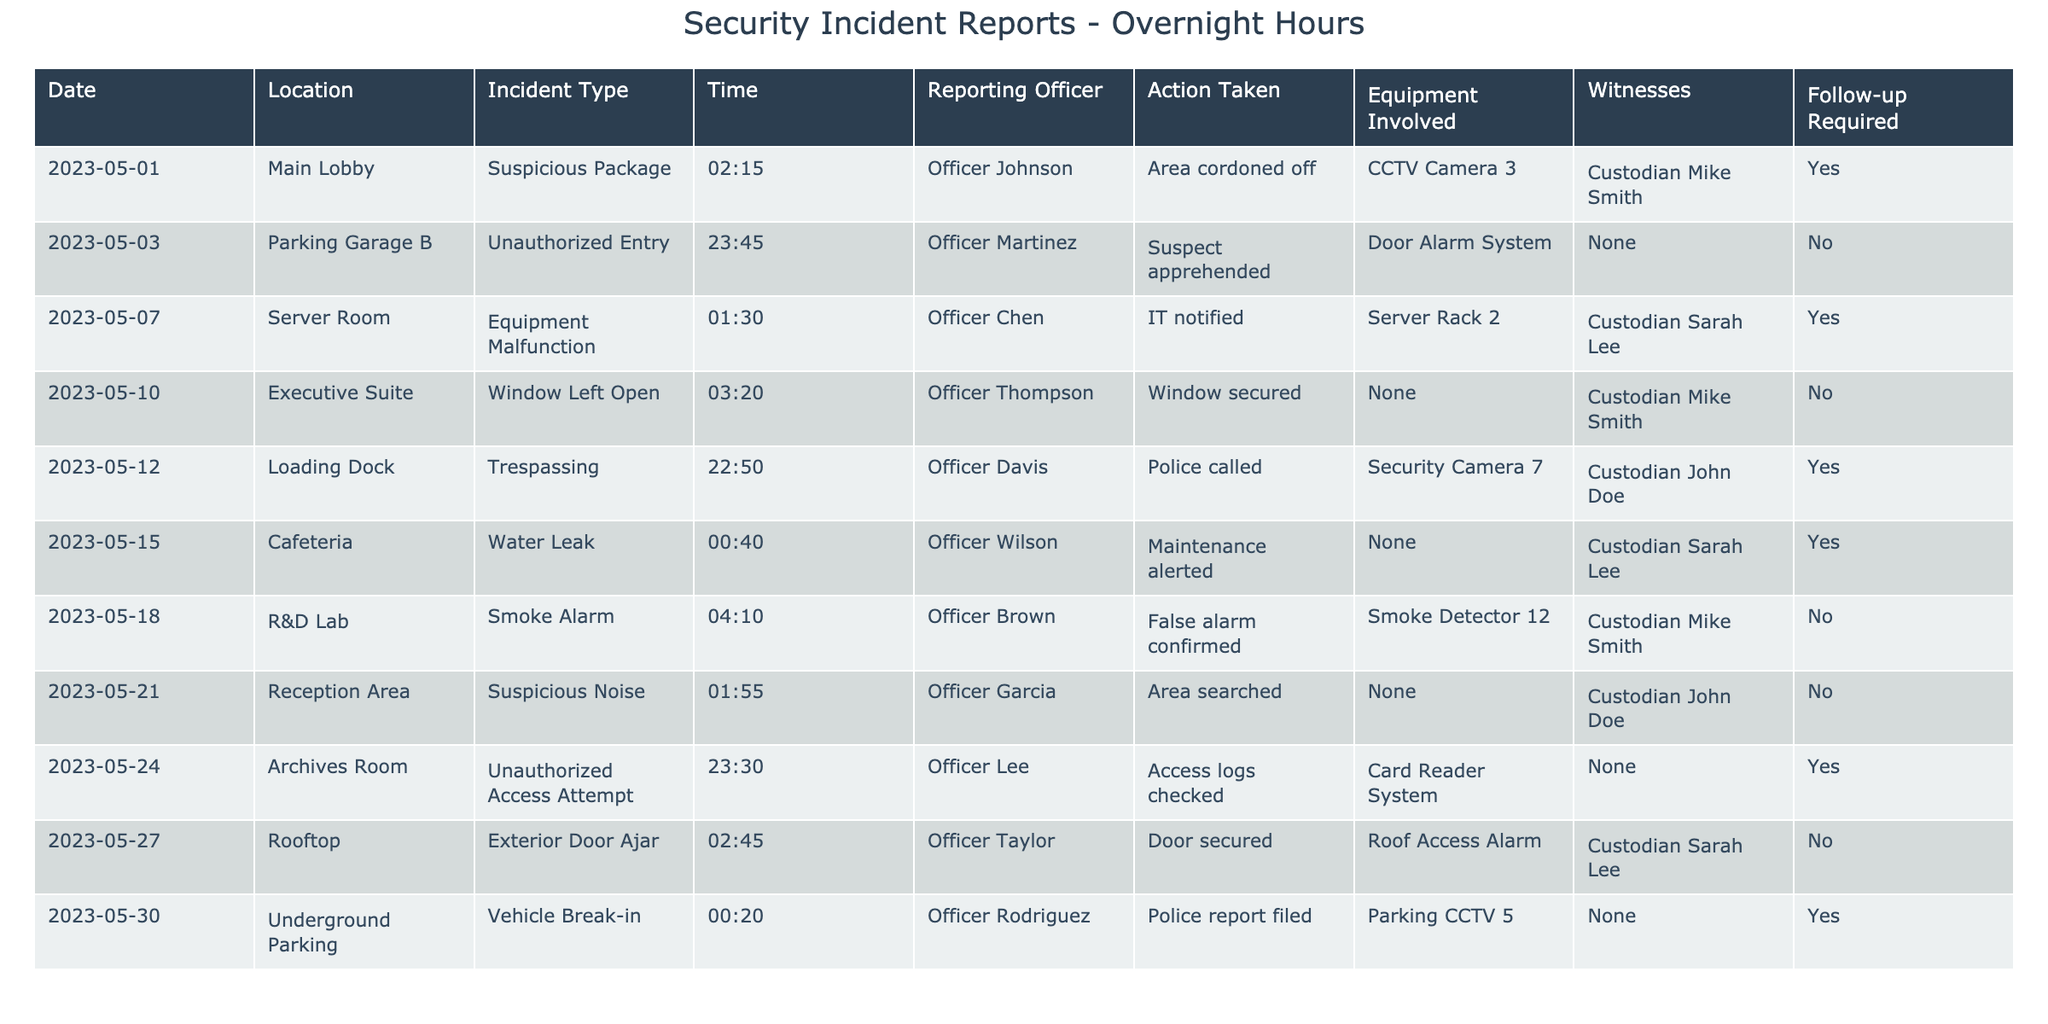What incident occurred at the Server Room? Referring to the table, the incident type listed for the Server Room is "Equipment Malfunction."
Answer: Equipment Malfunction How many incidents required a follow-up? By scanning the table, I can see that there are three instances where "Yes" is indicated under the "Follow-up Required" column: May 1, May 7, and May 12.
Answer: 3 What time did the water leak incident occur? Looking at the table, the water leak incident occurred at "00:40" on May 15.
Answer: 00:40 Which officer reported the unauthorized entry in Parking Garage B? The table shows that Officer Martinez was the reporting officer for the unauthorized entry incident in Parking Garage B.
Answer: Officer Martinez How many incidents occurred after midnight? Counting the rows in the table where the time is post-00:00 (4 entries: May 7, May 15, May 18, May 30), there were four incidents after midnight.
Answer: 4 Did any incidents require police involvement? The table indicates that two incidents required police involvement: the unauthorized entry and the trespassing on May 12.
Answer: Yes What was the action taken for the suspicious package reported on May 1? The table states that for the suspicious package incident, the area was cordoned off.
Answer: Area cordoned off Which piece of equipment was involved in the vehicle break-in? According to the table, the equipment involved in the vehicle break-in on May 30 was the Parking CCTV 5.
Answer: Parking CCTV 5 Which location had the highest number of incidents? By examining the table, I find that the Parking Garage B had one incident, while other locations like the Main Lobby and Loading Dock also had one incident, indicating no single location is repeated.
Answer: All locations had one incident What was the outcome of the smoke alarm incident? The table indicates that for the smoke alarm incident in the R&D Lab, it was confirmed as a false alarm after investigation.
Answer: False alarm confirmed What is the average time of the incidents listed? To find the average, convert the times to minutes since midnight, sum them (135 + 1425 + 90 + 200 + 745 + 40 + 250 + 130 + 2 + 20) = 2832 minutes and divide by the number of incidents (10). The average time is 2832/10 = 283.2 minutes or approximately 4 hours and 43 minutes post-midnight.
Answer: 04:43 